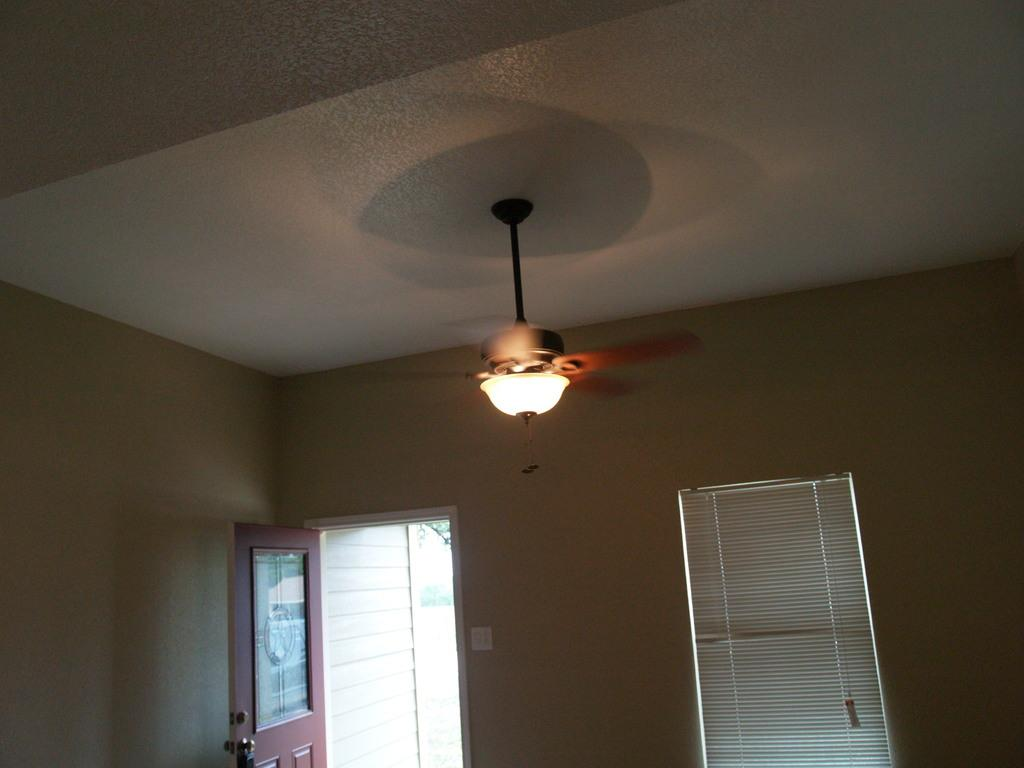What is attached to the ceiling in the image? There is a fan fixed to the ceiling in the image. What is located in the middle of the image? There is a light in the middle of the image. What can be seen in the background of the image? There is a door and a wall in the background of the image. What type of behavior can be observed in the team of animals in the image? There are no animals or teams present in the image; it only features a fan, a light, a door, and a wall. 